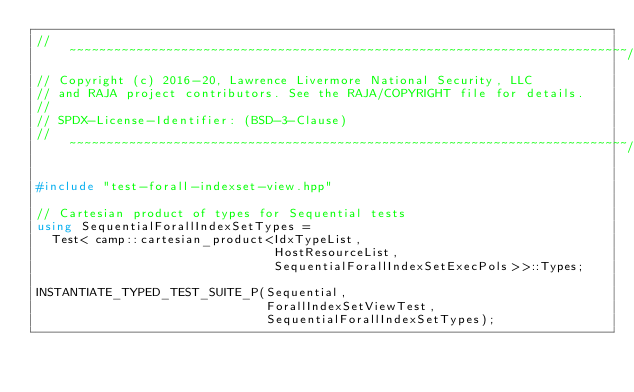Convert code to text. <code><loc_0><loc_0><loc_500><loc_500><_C++_>//~~~~~~~~~~~~~~~~~~~~~~~~~~~~~~~~~~~~~~~~~~~~~~~~~~~~~~~~~~~~~~~~~~~~~~~~~~~//
// Copyright (c) 2016-20, Lawrence Livermore National Security, LLC
// and RAJA project contributors. See the RAJA/COPYRIGHT file for details.
//
// SPDX-License-Identifier: (BSD-3-Clause)
//~~~~~~~~~~~~~~~~~~~~~~~~~~~~~~~~~~~~~~~~~~~~~~~~~~~~~~~~~~~~~~~~~~~~~~~~~~~//

#include "test-forall-indexset-view.hpp"

// Cartesian product of types for Sequential tests
using SequentialForallIndexSetTypes =
  Test< camp::cartesian_product<IdxTypeList, 
                                HostResourceList, 
                                SequentialForallIndexSetExecPols>>::Types;

INSTANTIATE_TYPED_TEST_SUITE_P(Sequential,
                               ForallIndexSetViewTest,
                               SequentialForallIndexSetTypes);
</code> 